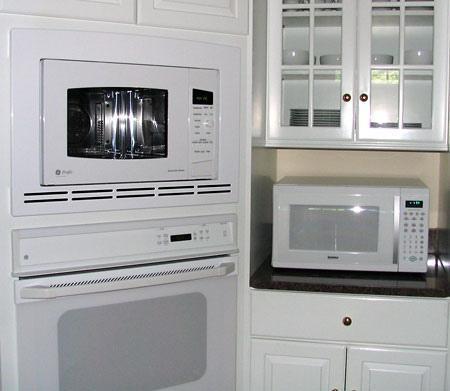How many bowls are in the cabinet?
Give a very brief answer. 4. How many microwaves are there?
Give a very brief answer. 2. 